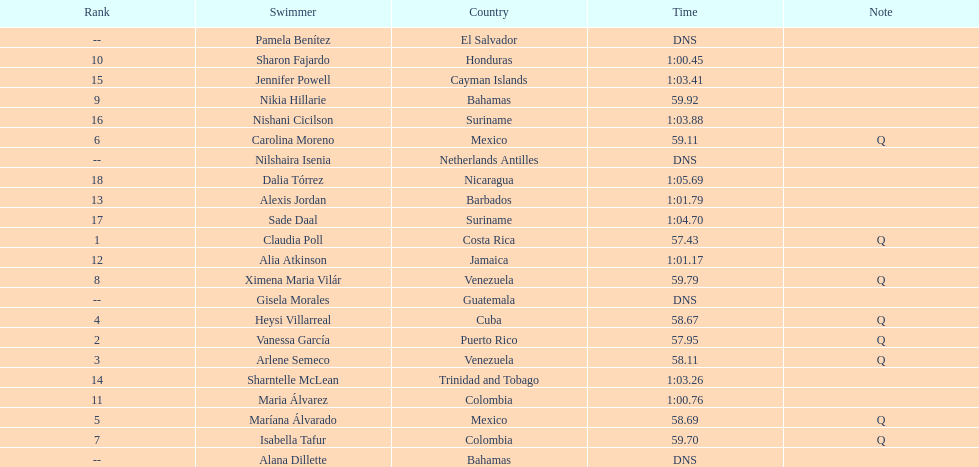Who was the only cuban to finish in the top eight? Heysi Villarreal. 